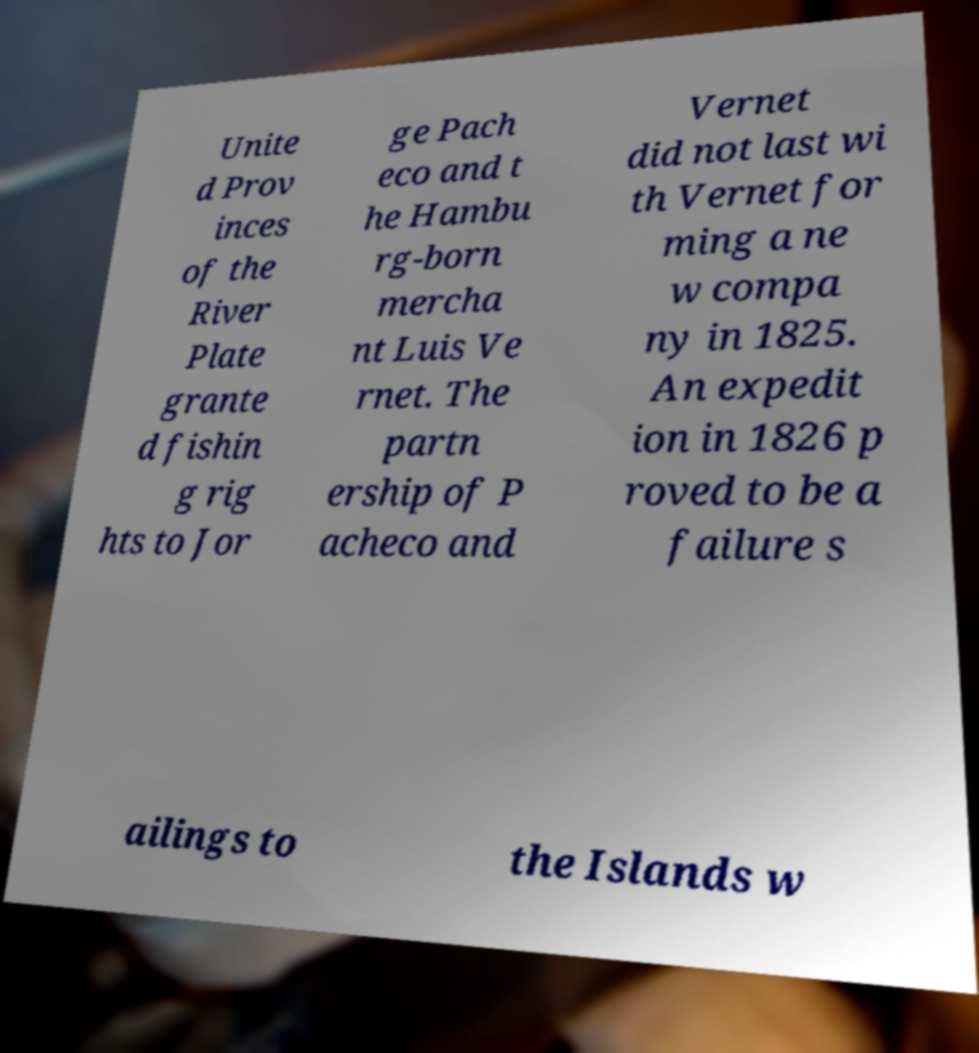What messages or text are displayed in this image? I need them in a readable, typed format. Unite d Prov inces of the River Plate grante d fishin g rig hts to Jor ge Pach eco and t he Hambu rg-born mercha nt Luis Ve rnet. The partn ership of P acheco and Vernet did not last wi th Vernet for ming a ne w compa ny in 1825. An expedit ion in 1826 p roved to be a failure s ailings to the Islands w 